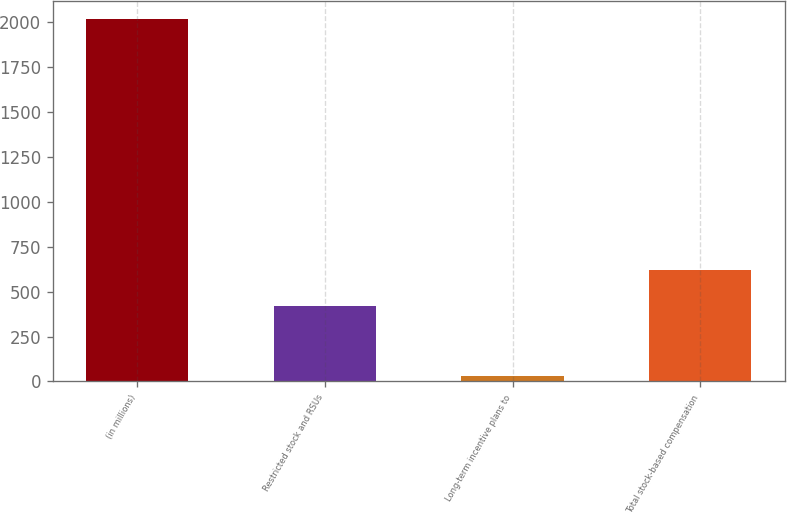Convert chart. <chart><loc_0><loc_0><loc_500><loc_500><bar_chart><fcel>(in millions)<fcel>Restricted stock and RSUs<fcel>Long-term incentive plans to<fcel>Total stock-based compensation<nl><fcel>2014<fcel>421<fcel>32<fcel>619.2<nl></chart> 